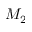Convert formula to latex. <formula><loc_0><loc_0><loc_500><loc_500>M _ { 2 }</formula> 